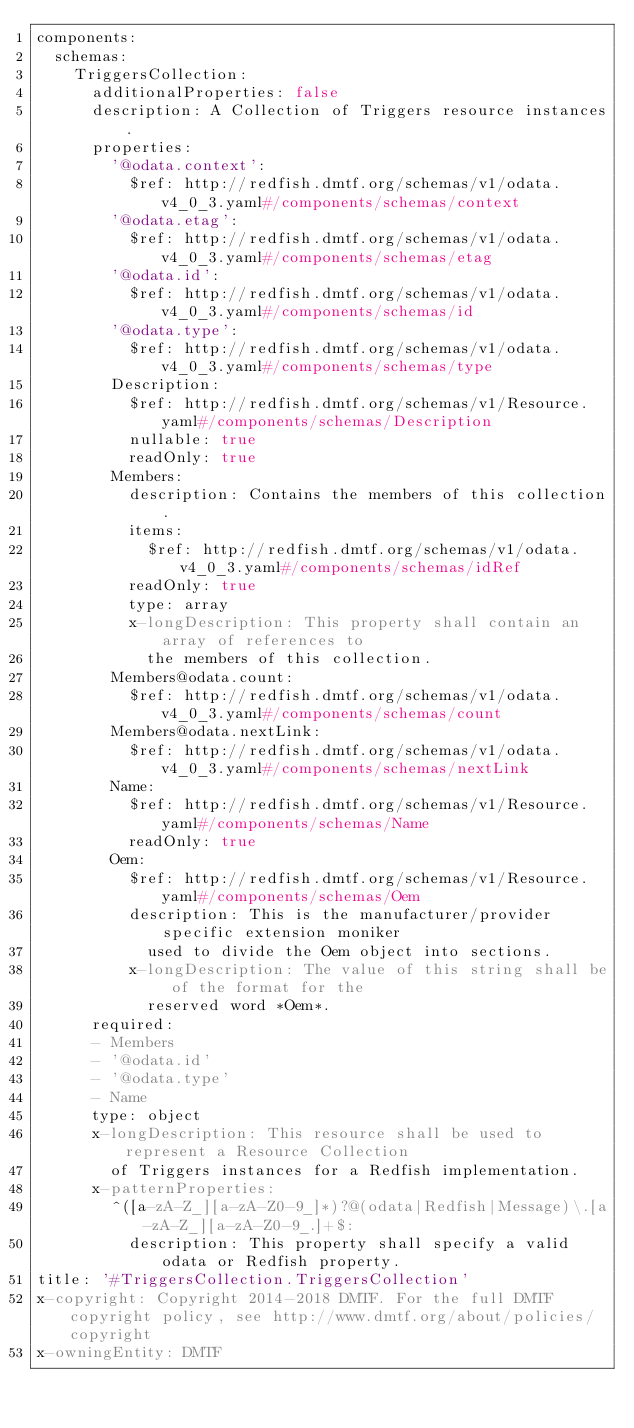<code> <loc_0><loc_0><loc_500><loc_500><_YAML_>components:
  schemas:
    TriggersCollection:
      additionalProperties: false
      description: A Collection of Triggers resource instances.
      properties:
        '@odata.context':
          $ref: http://redfish.dmtf.org/schemas/v1/odata.v4_0_3.yaml#/components/schemas/context
        '@odata.etag':
          $ref: http://redfish.dmtf.org/schemas/v1/odata.v4_0_3.yaml#/components/schemas/etag
        '@odata.id':
          $ref: http://redfish.dmtf.org/schemas/v1/odata.v4_0_3.yaml#/components/schemas/id
        '@odata.type':
          $ref: http://redfish.dmtf.org/schemas/v1/odata.v4_0_3.yaml#/components/schemas/type
        Description:
          $ref: http://redfish.dmtf.org/schemas/v1/Resource.yaml#/components/schemas/Description
          nullable: true
          readOnly: true
        Members:
          description: Contains the members of this collection.
          items:
            $ref: http://redfish.dmtf.org/schemas/v1/odata.v4_0_3.yaml#/components/schemas/idRef
          readOnly: true
          type: array
          x-longDescription: This property shall contain an array of references to
            the members of this collection.
        Members@odata.count:
          $ref: http://redfish.dmtf.org/schemas/v1/odata.v4_0_3.yaml#/components/schemas/count
        Members@odata.nextLink:
          $ref: http://redfish.dmtf.org/schemas/v1/odata.v4_0_3.yaml#/components/schemas/nextLink
        Name:
          $ref: http://redfish.dmtf.org/schemas/v1/Resource.yaml#/components/schemas/Name
          readOnly: true
        Oem:
          $ref: http://redfish.dmtf.org/schemas/v1/Resource.yaml#/components/schemas/Oem
          description: This is the manufacturer/provider specific extension moniker
            used to divide the Oem object into sections.
          x-longDescription: The value of this string shall be of the format for the
            reserved word *Oem*.
      required:
      - Members
      - '@odata.id'
      - '@odata.type'
      - Name
      type: object
      x-longDescription: This resource shall be used to represent a Resource Collection
        of Triggers instances for a Redfish implementation.
      x-patternProperties:
        ^([a-zA-Z_][a-zA-Z0-9_]*)?@(odata|Redfish|Message)\.[a-zA-Z_][a-zA-Z0-9_.]+$:
          description: This property shall specify a valid odata or Redfish property.
title: '#TriggersCollection.TriggersCollection'
x-copyright: Copyright 2014-2018 DMTF. For the full DMTF copyright policy, see http://www.dmtf.org/about/policies/copyright
x-owningEntity: DMTF
</code> 